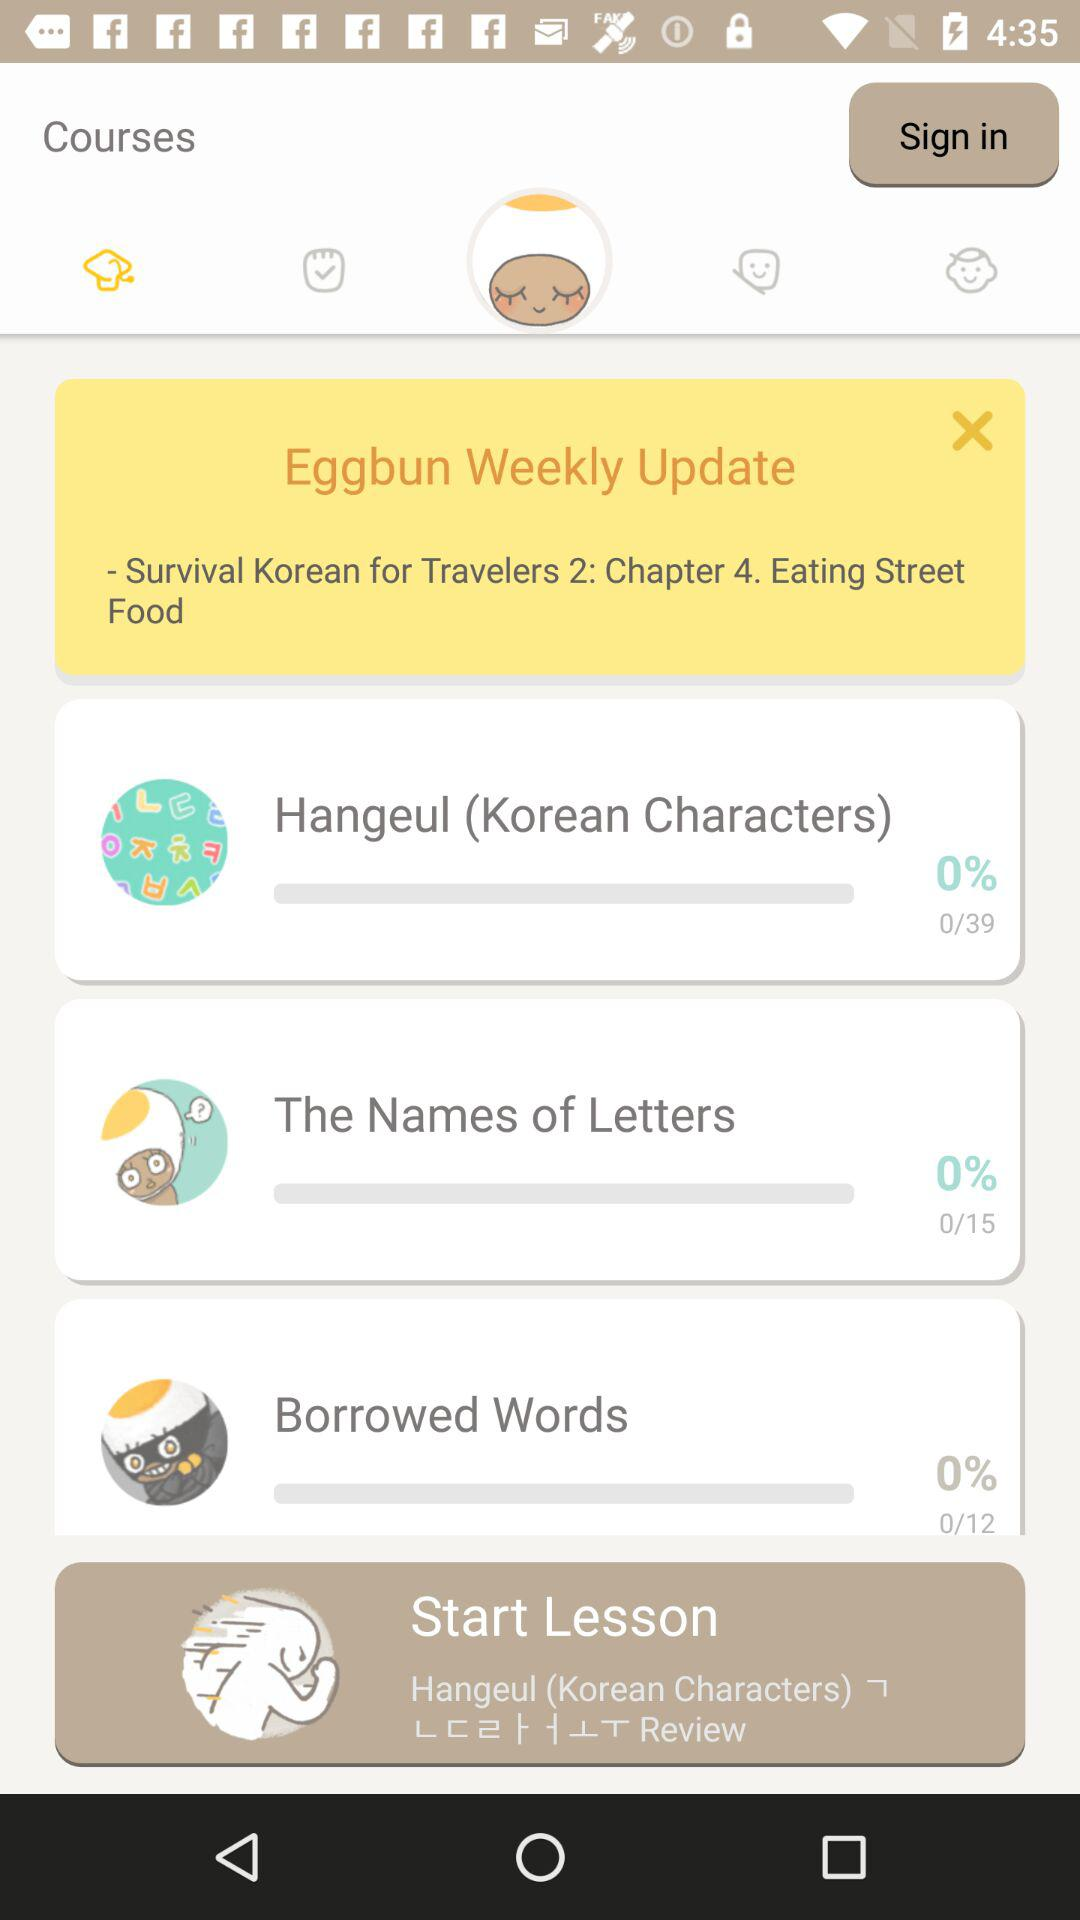How many lessons have you completed in the Survival Korean for Travelers 2 course?
Answer the question using a single word or phrase. 0 